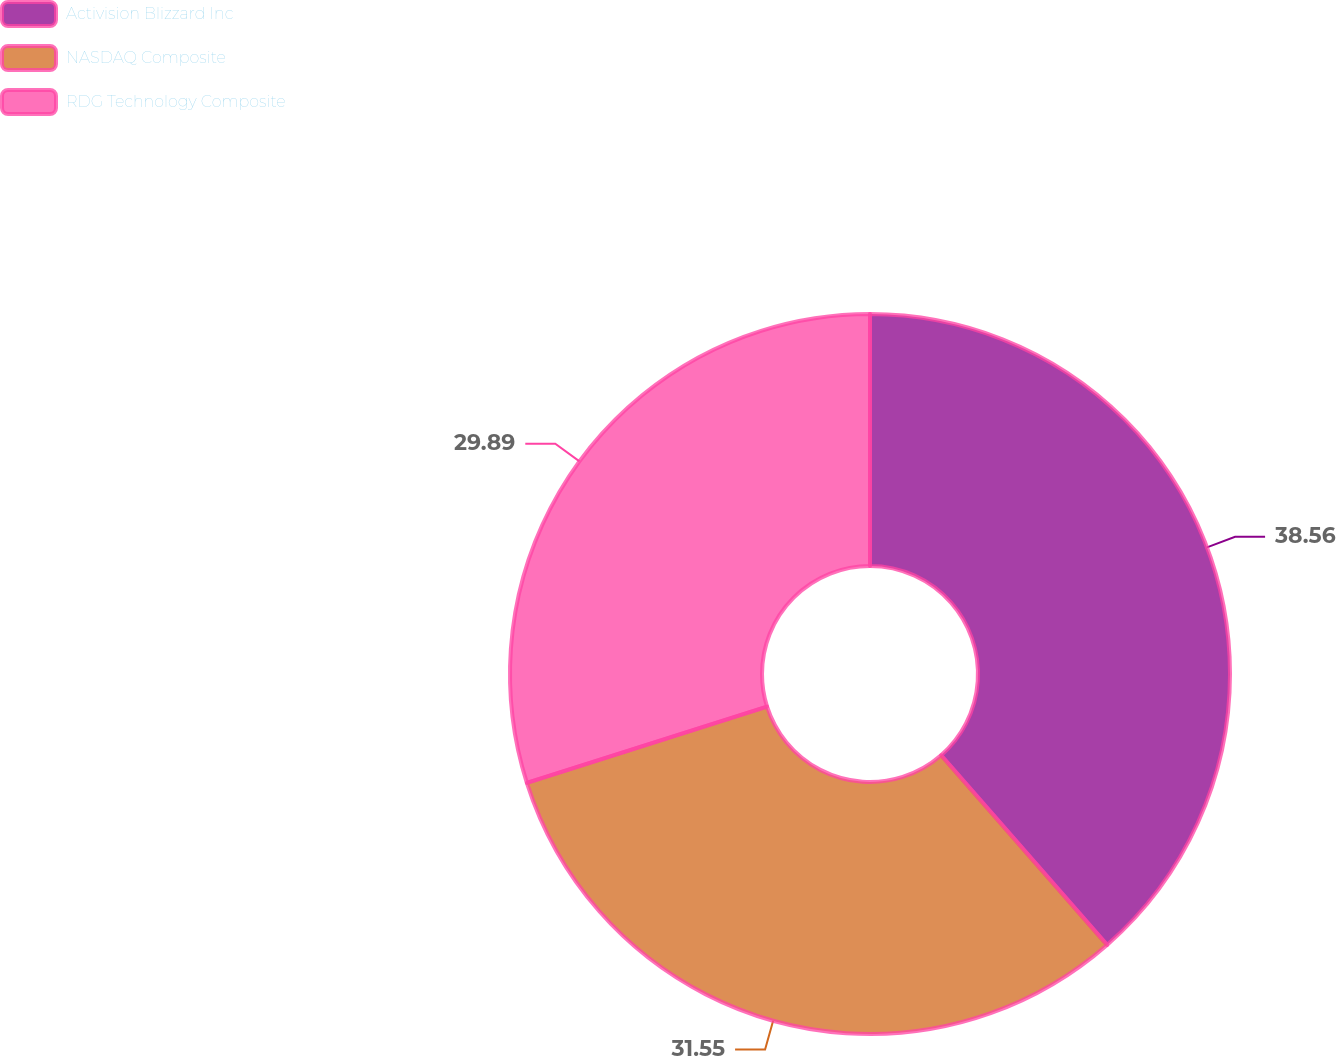Convert chart to OTSL. <chart><loc_0><loc_0><loc_500><loc_500><pie_chart><fcel>Activision Blizzard Inc<fcel>NASDAQ Composite<fcel>RDG Technology Composite<nl><fcel>38.56%<fcel>31.55%<fcel>29.89%<nl></chart> 